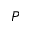<formula> <loc_0><loc_0><loc_500><loc_500>P</formula> 